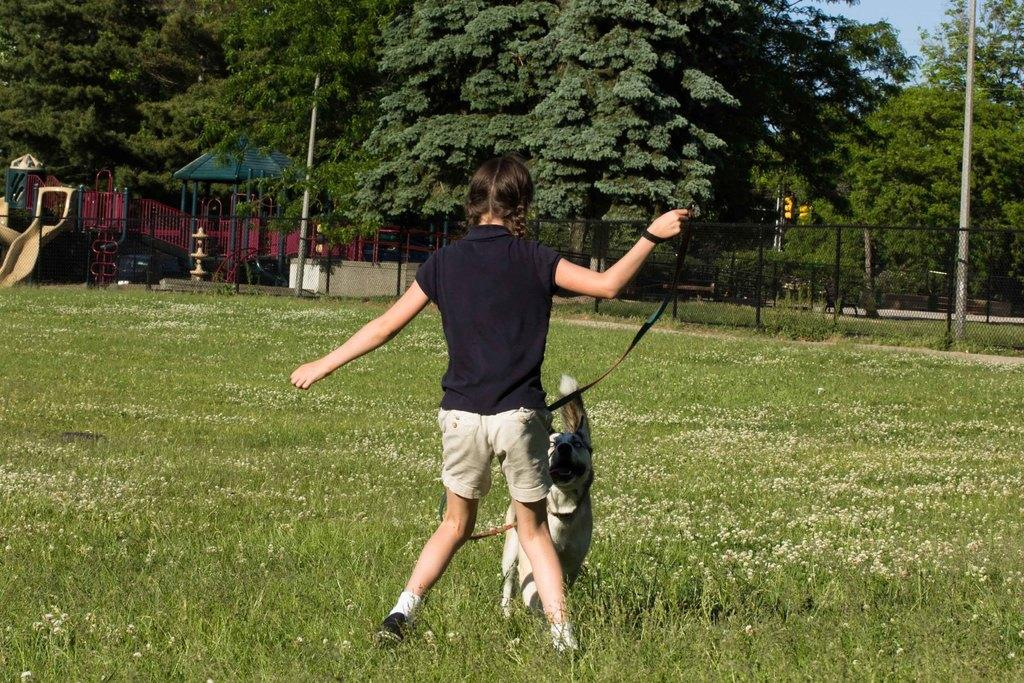Who is present in the image playing with a dog? There is a girl in the image playing with a dog. What is the setting where the girl and dog are playing? The girl and dog are on the grass in the image. What type of location is depicted in the image? There is a park in the image. What other natural elements can be seen in the image? There are trees in the image. How many times does the girl curve her body while playing with the dog in the image? There is no indication in the image of the girl curving her body while playing with the dog. What type of front is visible in the image? There is no specific "front" mentioned or visible in the image. --- 